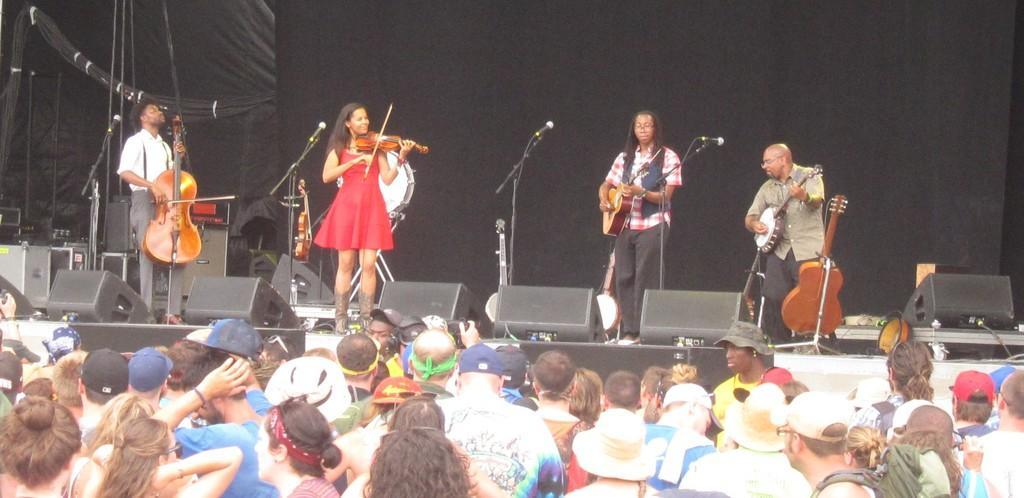How would you summarize this image in a sentence or two? Here in this picture we can see four people are are standing on the stage and playing musical instruments. The lady with red frock in the middle is playing a violin. And to the left corner a man is playing a violin. And the man with blue jacket and red checks shirt is playing a guitar. And the man to the right corner is playing guitar. There are four mics in front of them. Under the stage there are group of people standing and watching the performance. On the stage background there is black color cloth. We can see some speakers on the stage. 